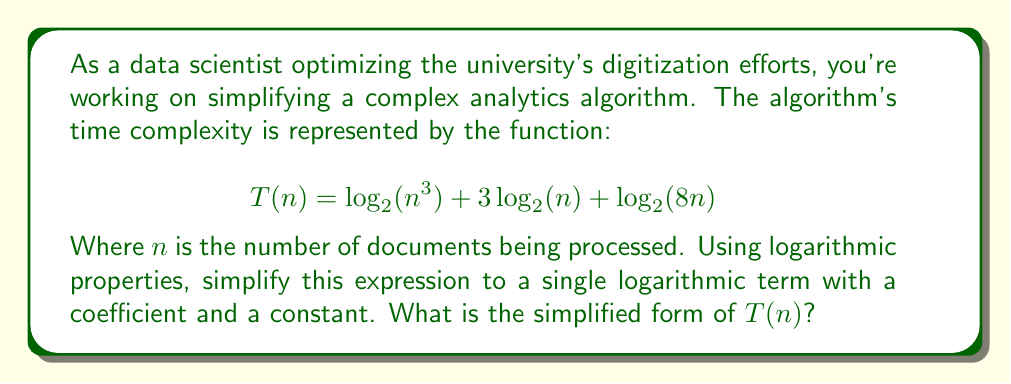Provide a solution to this math problem. Let's simplify this expression step by step using logarithmic properties:

1) First, let's apply the power property of logarithms to the first term:
   $$\log_2(n^3) = 3\log_2(n)$$

2) The expression now becomes:
   $$T(n) = 3\log_2(n) + 3\log_2(n) + \log_2(8n)$$

3) We can combine the first two terms:
   $$T(n) = 6\log_2(n) + \log_2(8n)$$

4) Now, let's focus on $\log_2(8n)$. We can use the product property of logarithms:
   $$\log_2(8n) = \log_2(8) + \log_2(n)$$

5) We know that $\log_2(8) = 3$ (because $2^3 = 8$), so:
   $$\log_2(8n) = 3 + \log_2(n)$$

6) Substituting this back into our expression:
   $$T(n) = 6\log_2(n) + (3 + \log_2(n))$$

7) Simplifying:
   $$T(n) = 6\log_2(n) + \log_2(n) + 3$$
   $$T(n) = 7\log_2(n) + 3$$

This is our final simplified form, with a single logarithmic term with a coefficient of 7 and a constant term of 3.
Answer: $$T(n) = 7\log_2(n) + 3$$ 